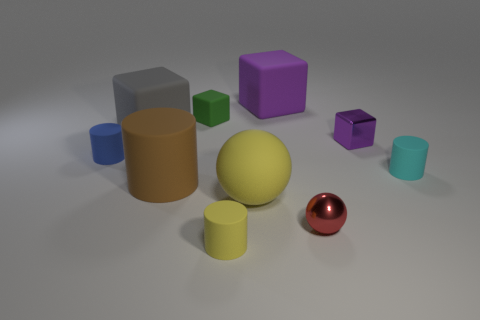Subtract all tiny cyan cylinders. How many cylinders are left? 3 Subtract all blue cylinders. How many cylinders are left? 3 Subtract all balls. How many objects are left? 8 Subtract all yellow cylinders. How many purple cubes are left? 2 Subtract 2 balls. How many balls are left? 0 Add 8 small yellow cylinders. How many small yellow cylinders exist? 9 Subtract 1 gray blocks. How many objects are left? 9 Subtract all yellow cylinders. Subtract all brown balls. How many cylinders are left? 3 Subtract all large purple spheres. Subtract all blue matte cylinders. How many objects are left? 9 Add 4 tiny purple objects. How many tiny purple objects are left? 5 